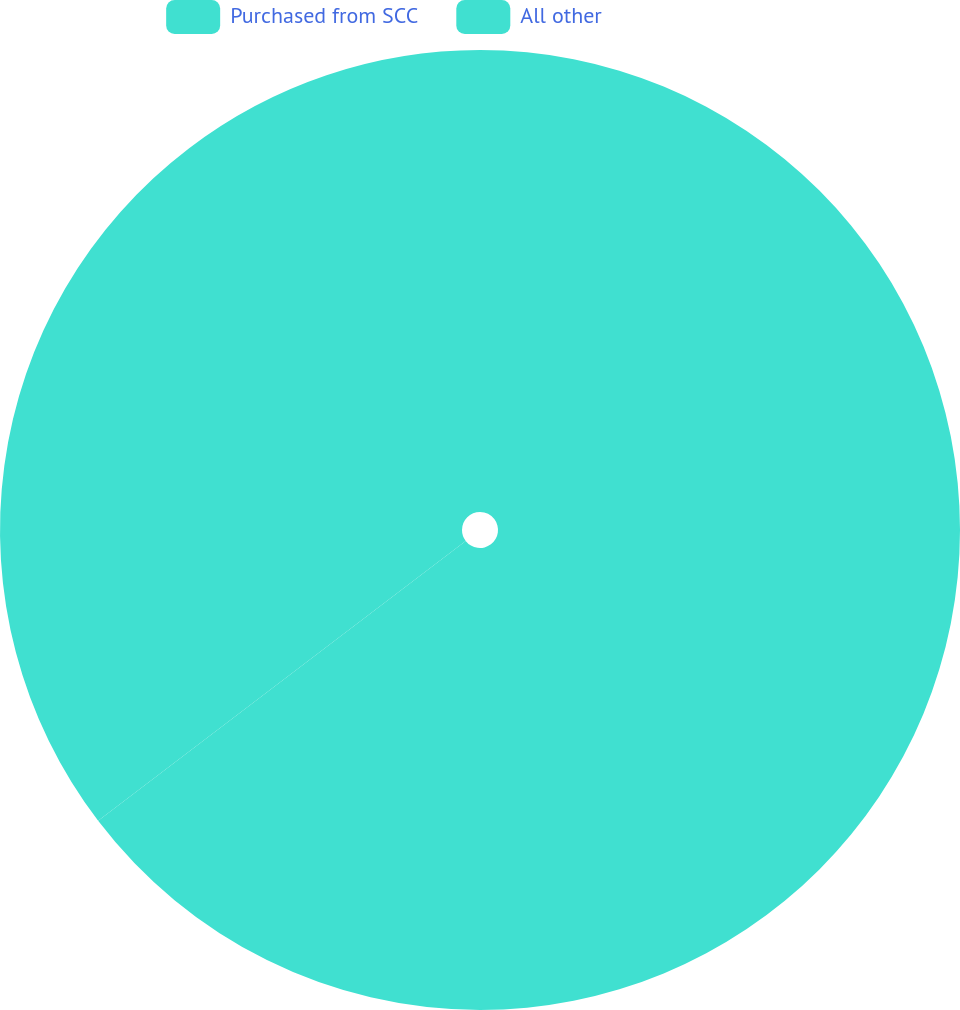Convert chart to OTSL. <chart><loc_0><loc_0><loc_500><loc_500><pie_chart><fcel>Purchased from SCC<fcel>All other<nl><fcel>64.64%<fcel>35.36%<nl></chart> 